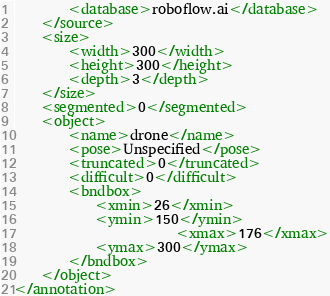Convert code to text. <code><loc_0><loc_0><loc_500><loc_500><_XML_>		<database>roboflow.ai</database>
	</source>
	<size>
		<width>300</width>
		<height>300</height>
		<depth>3</depth>
	</size>
	<segmented>0</segmented>
	<object>
		<name>drone</name>
		<pose>Unspecified</pose>
		<truncated>0</truncated>
		<difficult>0</difficult>
		<bndbox>
			<xmin>26</xmin>
			<ymin>150</ymin>
                        <xmax>176</xmax>
			<ymax>300</ymax>
		</bndbox>
	</object>
</annotation>
</code> 